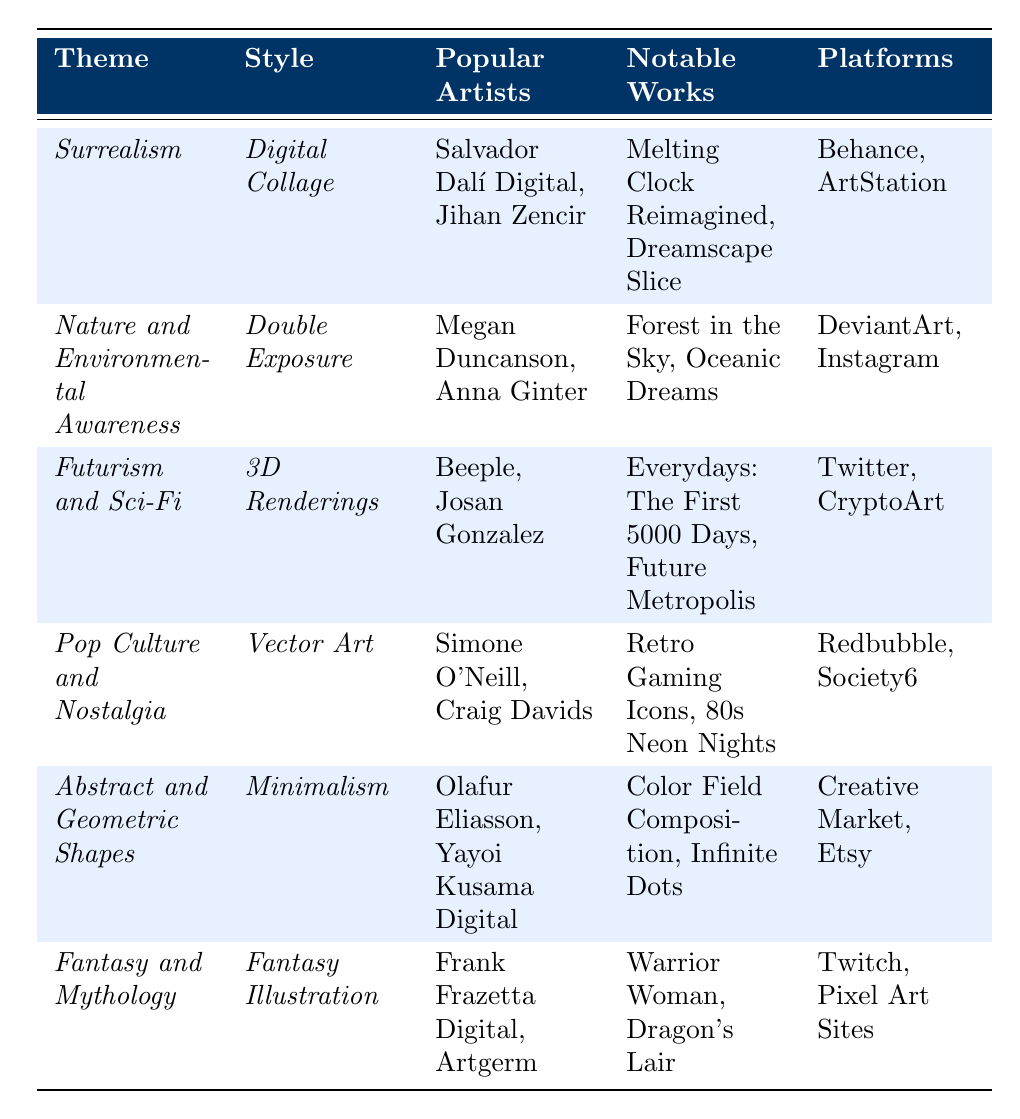What is the style associated with *Futurism and Sci-Fi*? Referring to the table, the style linked to the theme *Futurism and Sci-Fi* is *3D Renderings*.
Answer: 3D Renderings Who are two popular artists associated with *Nature and Environmental Awareness*? The table lists Megan Duncanson and Anna Ginter as popular artists for the theme *Nature and Environmental Awareness*.
Answer: Megan Duncanson, Anna Ginter Is *Digital Collage* mentioned as a style under the theme *Surrealism*? Yes, the table clearly states that *Digital Collage* is the style associated with the theme *Surrealism*.
Answer: Yes Which platforms are associated with the style of *Fantasy Illustration*? Looking at the table, *Fantasy Illustration* is associated with platforms like Twitch and Pixel Art Sites.
Answer: Twitch, Pixel Art Sites Can you identify a notable work from the theme *Pop Culture and Nostalgia*? The table shows that notable works under *Pop Culture and Nostalgia* include "Retro Gaming Icons" and "80s Neon Nights".
Answer: Retro Gaming Icons, 80s Neon Nights What themes are associated with *Vector Art* and *Double Exposure* styles? By inspecting the table, *Vector Art* is linked to the theme *Pop Culture and Nostalgia*, while *Double Exposure* corresponds to *Nature and Environmental Awareness*.
Answer: Pop Culture and Nostalgia, Nature and Environmental Awareness How many artists are mentioned in the context of *Abstract and Geometric Shapes*? The table indicates two popular artists for the theme *Abstract and Geometric Shapes*: Olafur Eliasson and Yayoi Kusama Digital.
Answer: 2 What are the common platforms used by artists focused on *Futurism and Sci-Fi*? According to the table, artists focused on *Futurism and Sci-Fi* commonly use platforms like Twitter and CryptoArt.
Answer: Twitter, CryptoArt Which theme has the most notable works listed? The table does not provide a direct count for comparisons, but it lists the same number of notable works for each theme, making them equally represented with two notable works each.
Answer: Equal representation Are there any artists listed under more than one theme? The data does not indicate if any artists appear in multiple themes since all listed artists are unique to their respective themes.
Answer: No 